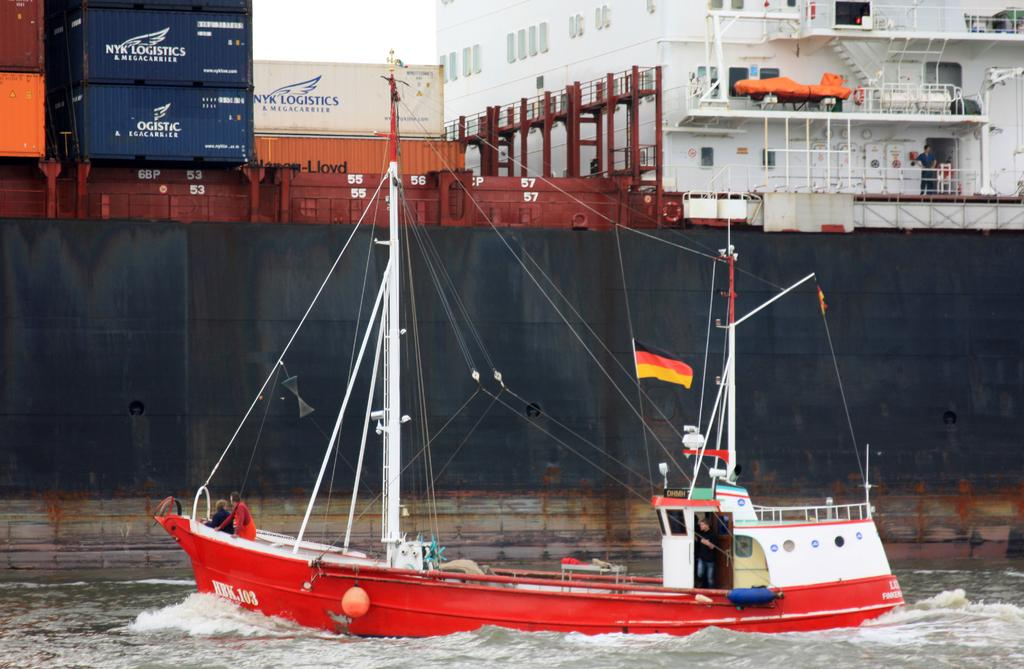What is the main subject in the center of the image? There is a ship in the center of the image. What is the ship's location in relation to the water? The ship is on the water surface. Are there any people on the ship? Yes, there are people on the ship. What else can be seen on the ship besides people? There are containers on the ship. What can be seen in the background of the image? There is a building structure and a man in the background, as well as the sky. What attempt does the man in the background make to shock the ship? There is no indication in the image that the man in the background is attempting to shock the ship or that any shock is involved. 